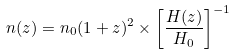<formula> <loc_0><loc_0><loc_500><loc_500>n ( z ) = n _ { 0 } ( 1 + z ) ^ { 2 } \times \left [ \frac { H ( z ) } { H _ { 0 } } \right ] ^ { - 1 }</formula> 